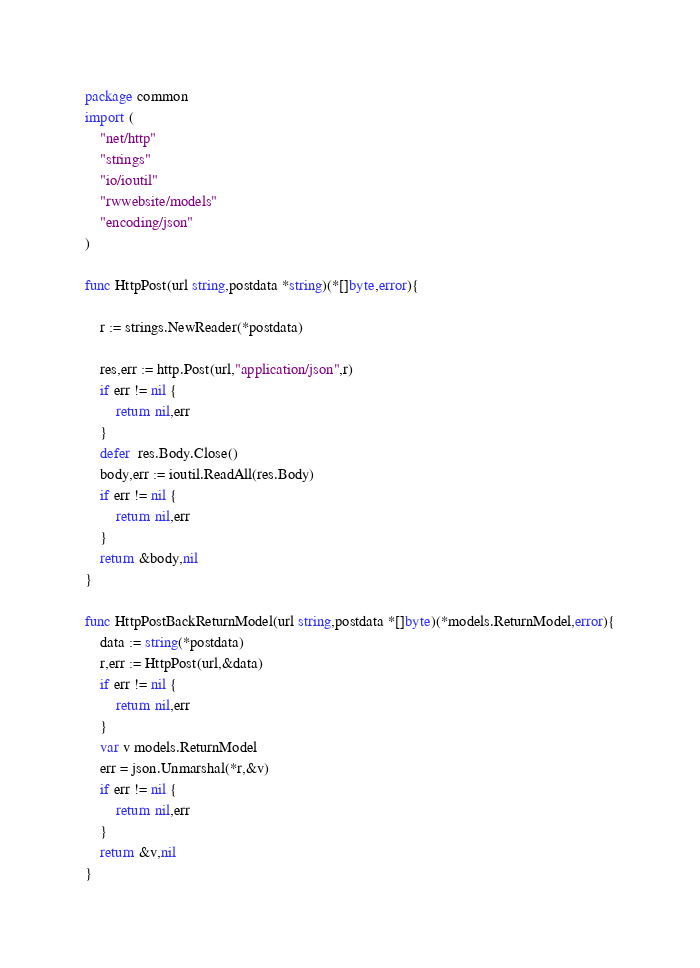Convert code to text. <code><loc_0><loc_0><loc_500><loc_500><_Go_>package common
import (
	"net/http"
	"strings"
	"io/ioutil"
	"rwwebsite/models"
	"encoding/json"
)

func HttpPost(url string,postdata *string)(*[]byte,error){

	r := strings.NewReader(*postdata)

	res,err := http.Post(url,"application/json",r)
	if err != nil {
		return nil,err
	}
	defer  res.Body.Close()
	body,err := ioutil.ReadAll(res.Body)
	if err != nil {
		return nil,err
	}
	return &body,nil
}

func HttpPostBackReturnModel(url string,postdata *[]byte)(*models.ReturnModel,error){
	data := string(*postdata)
	r,err := HttpPost(url,&data)
	if err != nil {
		return nil,err
	}
	var v models.ReturnModel
	err = json.Unmarshal(*r,&v)
	if err != nil {
		return nil,err
	}
	return &v,nil
}</code> 